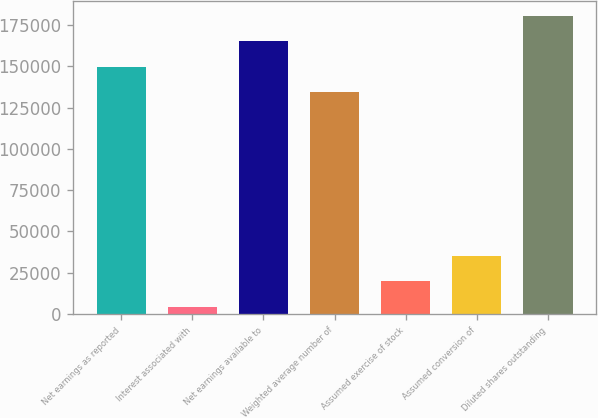Convert chart to OTSL. <chart><loc_0><loc_0><loc_500><loc_500><bar_chart><fcel>Net earnings as reported<fcel>Interest associated with<fcel>Net earnings available to<fcel>Weighted average number of<fcel>Assumed exercise of stock<fcel>Assumed conversion of<fcel>Diluted shares outstanding<nl><fcel>149726<fcel>4426<fcel>165207<fcel>134244<fcel>19907.5<fcel>35389<fcel>180688<nl></chart> 